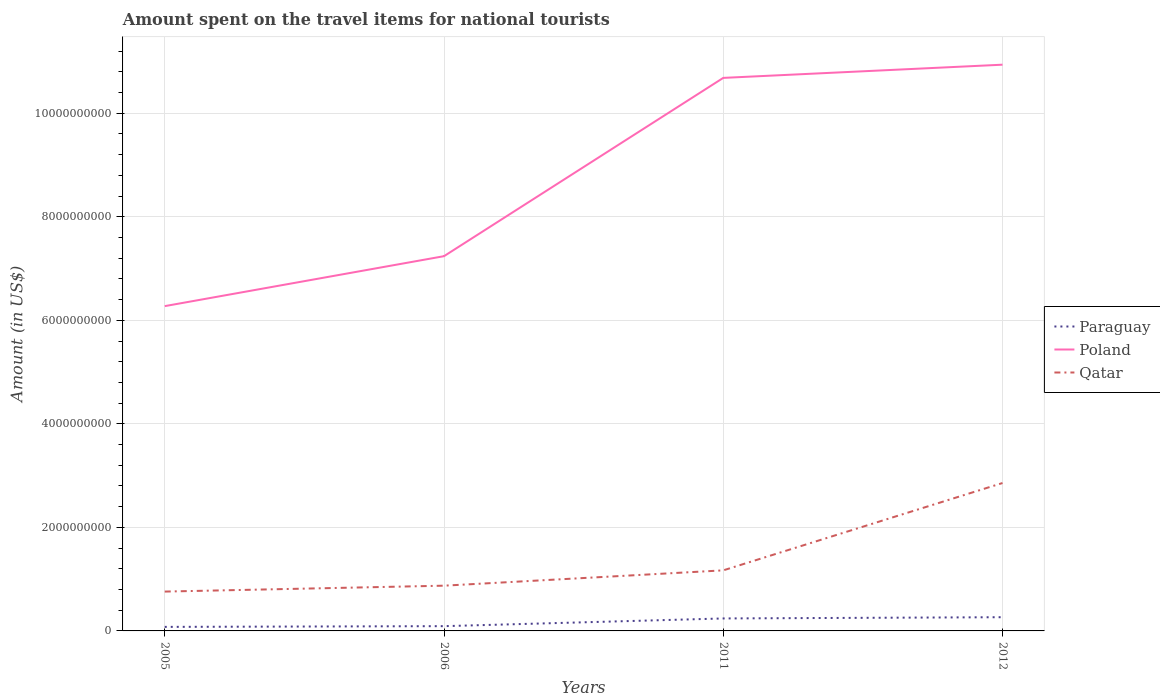How many different coloured lines are there?
Provide a short and direct response. 3. Is the number of lines equal to the number of legend labels?
Offer a very short reply. Yes. Across all years, what is the maximum amount spent on the travel items for national tourists in Poland?
Give a very brief answer. 6.27e+09. In which year was the amount spent on the travel items for national tourists in Qatar maximum?
Provide a succinct answer. 2005. What is the total amount spent on the travel items for national tourists in Qatar in the graph?
Provide a short and direct response. -1.98e+09. What is the difference between the highest and the second highest amount spent on the travel items for national tourists in Poland?
Your answer should be very brief. 4.66e+09. What is the difference between the highest and the lowest amount spent on the travel items for national tourists in Qatar?
Make the answer very short. 1. Is the amount spent on the travel items for national tourists in Qatar strictly greater than the amount spent on the travel items for national tourists in Paraguay over the years?
Make the answer very short. No. How many lines are there?
Make the answer very short. 3. What is the difference between two consecutive major ticks on the Y-axis?
Ensure brevity in your answer.  2.00e+09. Are the values on the major ticks of Y-axis written in scientific E-notation?
Make the answer very short. No. Where does the legend appear in the graph?
Offer a very short reply. Center right. How are the legend labels stacked?
Offer a very short reply. Vertical. What is the title of the graph?
Ensure brevity in your answer.  Amount spent on the travel items for national tourists. What is the label or title of the X-axis?
Your answer should be compact. Years. What is the Amount (in US$) of Paraguay in 2005?
Make the answer very short. 7.80e+07. What is the Amount (in US$) of Poland in 2005?
Keep it short and to the point. 6.27e+09. What is the Amount (in US$) in Qatar in 2005?
Provide a succinct answer. 7.60e+08. What is the Amount (in US$) of Paraguay in 2006?
Give a very brief answer. 9.20e+07. What is the Amount (in US$) in Poland in 2006?
Provide a short and direct response. 7.24e+09. What is the Amount (in US$) in Qatar in 2006?
Make the answer very short. 8.74e+08. What is the Amount (in US$) in Paraguay in 2011?
Your answer should be very brief. 2.41e+08. What is the Amount (in US$) in Poland in 2011?
Give a very brief answer. 1.07e+1. What is the Amount (in US$) in Qatar in 2011?
Provide a short and direct response. 1.17e+09. What is the Amount (in US$) in Paraguay in 2012?
Your answer should be compact. 2.65e+08. What is the Amount (in US$) in Poland in 2012?
Your answer should be very brief. 1.09e+1. What is the Amount (in US$) in Qatar in 2012?
Provide a short and direct response. 2.86e+09. Across all years, what is the maximum Amount (in US$) in Paraguay?
Provide a short and direct response. 2.65e+08. Across all years, what is the maximum Amount (in US$) of Poland?
Give a very brief answer. 1.09e+1. Across all years, what is the maximum Amount (in US$) of Qatar?
Make the answer very short. 2.86e+09. Across all years, what is the minimum Amount (in US$) of Paraguay?
Your answer should be very brief. 7.80e+07. Across all years, what is the minimum Amount (in US$) of Poland?
Give a very brief answer. 6.27e+09. Across all years, what is the minimum Amount (in US$) of Qatar?
Ensure brevity in your answer.  7.60e+08. What is the total Amount (in US$) of Paraguay in the graph?
Offer a very short reply. 6.76e+08. What is the total Amount (in US$) of Poland in the graph?
Offer a very short reply. 3.51e+1. What is the total Amount (in US$) of Qatar in the graph?
Your response must be concise. 5.66e+09. What is the difference between the Amount (in US$) in Paraguay in 2005 and that in 2006?
Provide a short and direct response. -1.40e+07. What is the difference between the Amount (in US$) in Poland in 2005 and that in 2006?
Ensure brevity in your answer.  -9.65e+08. What is the difference between the Amount (in US$) in Qatar in 2005 and that in 2006?
Your answer should be compact. -1.14e+08. What is the difference between the Amount (in US$) in Paraguay in 2005 and that in 2011?
Your answer should be very brief. -1.63e+08. What is the difference between the Amount (in US$) in Poland in 2005 and that in 2011?
Your answer should be compact. -4.41e+09. What is the difference between the Amount (in US$) in Qatar in 2005 and that in 2011?
Your answer should be very brief. -4.10e+08. What is the difference between the Amount (in US$) in Paraguay in 2005 and that in 2012?
Give a very brief answer. -1.87e+08. What is the difference between the Amount (in US$) of Poland in 2005 and that in 2012?
Your answer should be compact. -4.66e+09. What is the difference between the Amount (in US$) of Qatar in 2005 and that in 2012?
Your answer should be very brief. -2.10e+09. What is the difference between the Amount (in US$) in Paraguay in 2006 and that in 2011?
Ensure brevity in your answer.  -1.49e+08. What is the difference between the Amount (in US$) of Poland in 2006 and that in 2011?
Your response must be concise. -3.44e+09. What is the difference between the Amount (in US$) in Qatar in 2006 and that in 2011?
Your answer should be compact. -2.96e+08. What is the difference between the Amount (in US$) in Paraguay in 2006 and that in 2012?
Give a very brief answer. -1.73e+08. What is the difference between the Amount (in US$) of Poland in 2006 and that in 2012?
Keep it short and to the point. -3.70e+09. What is the difference between the Amount (in US$) of Qatar in 2006 and that in 2012?
Provide a short and direct response. -1.98e+09. What is the difference between the Amount (in US$) of Paraguay in 2011 and that in 2012?
Keep it short and to the point. -2.40e+07. What is the difference between the Amount (in US$) in Poland in 2011 and that in 2012?
Your answer should be very brief. -2.55e+08. What is the difference between the Amount (in US$) of Qatar in 2011 and that in 2012?
Your answer should be compact. -1.69e+09. What is the difference between the Amount (in US$) in Paraguay in 2005 and the Amount (in US$) in Poland in 2006?
Offer a terse response. -7.16e+09. What is the difference between the Amount (in US$) in Paraguay in 2005 and the Amount (in US$) in Qatar in 2006?
Your answer should be compact. -7.96e+08. What is the difference between the Amount (in US$) in Poland in 2005 and the Amount (in US$) in Qatar in 2006?
Make the answer very short. 5.40e+09. What is the difference between the Amount (in US$) in Paraguay in 2005 and the Amount (in US$) in Poland in 2011?
Keep it short and to the point. -1.06e+1. What is the difference between the Amount (in US$) of Paraguay in 2005 and the Amount (in US$) of Qatar in 2011?
Your answer should be compact. -1.09e+09. What is the difference between the Amount (in US$) in Poland in 2005 and the Amount (in US$) in Qatar in 2011?
Your answer should be very brief. 5.10e+09. What is the difference between the Amount (in US$) of Paraguay in 2005 and the Amount (in US$) of Poland in 2012?
Your answer should be very brief. -1.09e+1. What is the difference between the Amount (in US$) of Paraguay in 2005 and the Amount (in US$) of Qatar in 2012?
Keep it short and to the point. -2.78e+09. What is the difference between the Amount (in US$) in Poland in 2005 and the Amount (in US$) in Qatar in 2012?
Keep it short and to the point. 3.42e+09. What is the difference between the Amount (in US$) in Paraguay in 2006 and the Amount (in US$) in Poland in 2011?
Offer a very short reply. -1.06e+1. What is the difference between the Amount (in US$) in Paraguay in 2006 and the Amount (in US$) in Qatar in 2011?
Give a very brief answer. -1.08e+09. What is the difference between the Amount (in US$) in Poland in 2006 and the Amount (in US$) in Qatar in 2011?
Keep it short and to the point. 6.07e+09. What is the difference between the Amount (in US$) in Paraguay in 2006 and the Amount (in US$) in Poland in 2012?
Your answer should be compact. -1.08e+1. What is the difference between the Amount (in US$) of Paraguay in 2006 and the Amount (in US$) of Qatar in 2012?
Your answer should be compact. -2.76e+09. What is the difference between the Amount (in US$) in Poland in 2006 and the Amount (in US$) in Qatar in 2012?
Your answer should be compact. 4.38e+09. What is the difference between the Amount (in US$) in Paraguay in 2011 and the Amount (in US$) in Poland in 2012?
Provide a succinct answer. -1.07e+1. What is the difference between the Amount (in US$) in Paraguay in 2011 and the Amount (in US$) in Qatar in 2012?
Give a very brief answer. -2.62e+09. What is the difference between the Amount (in US$) of Poland in 2011 and the Amount (in US$) of Qatar in 2012?
Provide a succinct answer. 7.83e+09. What is the average Amount (in US$) in Paraguay per year?
Your answer should be compact. 1.69e+08. What is the average Amount (in US$) in Poland per year?
Your answer should be very brief. 8.78e+09. What is the average Amount (in US$) of Qatar per year?
Your answer should be very brief. 1.42e+09. In the year 2005, what is the difference between the Amount (in US$) of Paraguay and Amount (in US$) of Poland?
Your answer should be compact. -6.20e+09. In the year 2005, what is the difference between the Amount (in US$) in Paraguay and Amount (in US$) in Qatar?
Offer a terse response. -6.82e+08. In the year 2005, what is the difference between the Amount (in US$) in Poland and Amount (in US$) in Qatar?
Your response must be concise. 5.51e+09. In the year 2006, what is the difference between the Amount (in US$) in Paraguay and Amount (in US$) in Poland?
Your response must be concise. -7.15e+09. In the year 2006, what is the difference between the Amount (in US$) of Paraguay and Amount (in US$) of Qatar?
Offer a terse response. -7.82e+08. In the year 2006, what is the difference between the Amount (in US$) of Poland and Amount (in US$) of Qatar?
Ensure brevity in your answer.  6.36e+09. In the year 2011, what is the difference between the Amount (in US$) of Paraguay and Amount (in US$) of Poland?
Provide a short and direct response. -1.04e+1. In the year 2011, what is the difference between the Amount (in US$) of Paraguay and Amount (in US$) of Qatar?
Ensure brevity in your answer.  -9.29e+08. In the year 2011, what is the difference between the Amount (in US$) of Poland and Amount (in US$) of Qatar?
Ensure brevity in your answer.  9.51e+09. In the year 2012, what is the difference between the Amount (in US$) in Paraguay and Amount (in US$) in Poland?
Provide a succinct answer. -1.07e+1. In the year 2012, what is the difference between the Amount (in US$) of Paraguay and Amount (in US$) of Qatar?
Ensure brevity in your answer.  -2.59e+09. In the year 2012, what is the difference between the Amount (in US$) in Poland and Amount (in US$) in Qatar?
Offer a very short reply. 8.08e+09. What is the ratio of the Amount (in US$) in Paraguay in 2005 to that in 2006?
Your response must be concise. 0.85. What is the ratio of the Amount (in US$) in Poland in 2005 to that in 2006?
Make the answer very short. 0.87. What is the ratio of the Amount (in US$) in Qatar in 2005 to that in 2006?
Give a very brief answer. 0.87. What is the ratio of the Amount (in US$) of Paraguay in 2005 to that in 2011?
Your answer should be very brief. 0.32. What is the ratio of the Amount (in US$) in Poland in 2005 to that in 2011?
Your answer should be very brief. 0.59. What is the ratio of the Amount (in US$) of Qatar in 2005 to that in 2011?
Make the answer very short. 0.65. What is the ratio of the Amount (in US$) of Paraguay in 2005 to that in 2012?
Your answer should be very brief. 0.29. What is the ratio of the Amount (in US$) of Poland in 2005 to that in 2012?
Your response must be concise. 0.57. What is the ratio of the Amount (in US$) of Qatar in 2005 to that in 2012?
Your answer should be very brief. 0.27. What is the ratio of the Amount (in US$) of Paraguay in 2006 to that in 2011?
Your response must be concise. 0.38. What is the ratio of the Amount (in US$) in Poland in 2006 to that in 2011?
Offer a very short reply. 0.68. What is the ratio of the Amount (in US$) of Qatar in 2006 to that in 2011?
Your answer should be very brief. 0.75. What is the ratio of the Amount (in US$) in Paraguay in 2006 to that in 2012?
Your answer should be very brief. 0.35. What is the ratio of the Amount (in US$) of Poland in 2006 to that in 2012?
Your answer should be compact. 0.66. What is the ratio of the Amount (in US$) in Qatar in 2006 to that in 2012?
Offer a terse response. 0.31. What is the ratio of the Amount (in US$) in Paraguay in 2011 to that in 2012?
Your response must be concise. 0.91. What is the ratio of the Amount (in US$) of Poland in 2011 to that in 2012?
Your answer should be very brief. 0.98. What is the ratio of the Amount (in US$) in Qatar in 2011 to that in 2012?
Make the answer very short. 0.41. What is the difference between the highest and the second highest Amount (in US$) in Paraguay?
Offer a very short reply. 2.40e+07. What is the difference between the highest and the second highest Amount (in US$) of Poland?
Keep it short and to the point. 2.55e+08. What is the difference between the highest and the second highest Amount (in US$) of Qatar?
Offer a terse response. 1.69e+09. What is the difference between the highest and the lowest Amount (in US$) of Paraguay?
Keep it short and to the point. 1.87e+08. What is the difference between the highest and the lowest Amount (in US$) of Poland?
Give a very brief answer. 4.66e+09. What is the difference between the highest and the lowest Amount (in US$) of Qatar?
Your answer should be compact. 2.10e+09. 